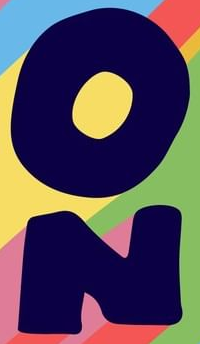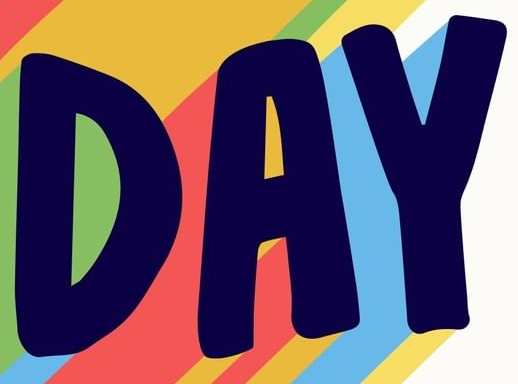What text appears in these images from left to right, separated by a semicolon? ON; DAY 